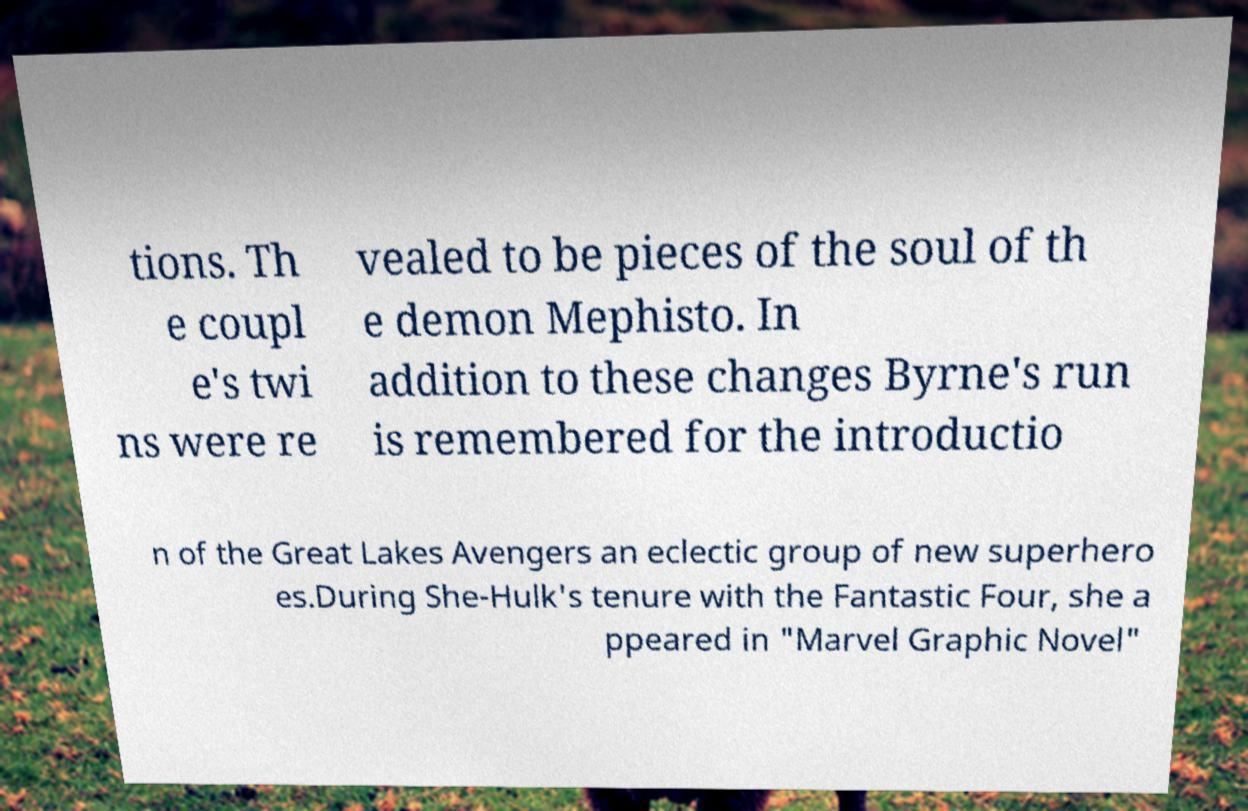Can you accurately transcribe the text from the provided image for me? tions. Th e coupl e's twi ns were re vealed to be pieces of the soul of th e demon Mephisto. In addition to these changes Byrne's run is remembered for the introductio n of the Great Lakes Avengers an eclectic group of new superhero es.During She-Hulk's tenure with the Fantastic Four, she a ppeared in "Marvel Graphic Novel" 